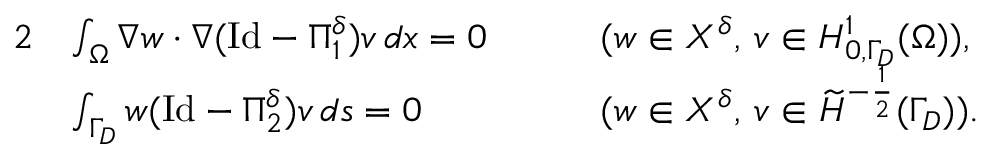<formula> <loc_0><loc_0><loc_500><loc_500>\begin{array} { r l r l } { 2 } & { \int _ { \Omega } \nabla w \cdot \nabla ( I d - \Pi _ { 1 } ^ { \delta } ) v \, d x = 0 \quad } & & { ( w \in X ^ { \delta } , \, v \in H _ { 0 , \Gamma _ { D } } ^ { 1 } ( \Omega ) ) , } \\ & { \int _ { \Gamma _ { D } } w ( I d - \Pi _ { 2 } ^ { \delta } ) v \, d s = 0 } & & { ( w \in X ^ { \delta } , \, v \in \widetilde { H } ^ { - \frac { 1 } { 2 } } ( \Gamma _ { D } ) ) . } \end{array}</formula> 